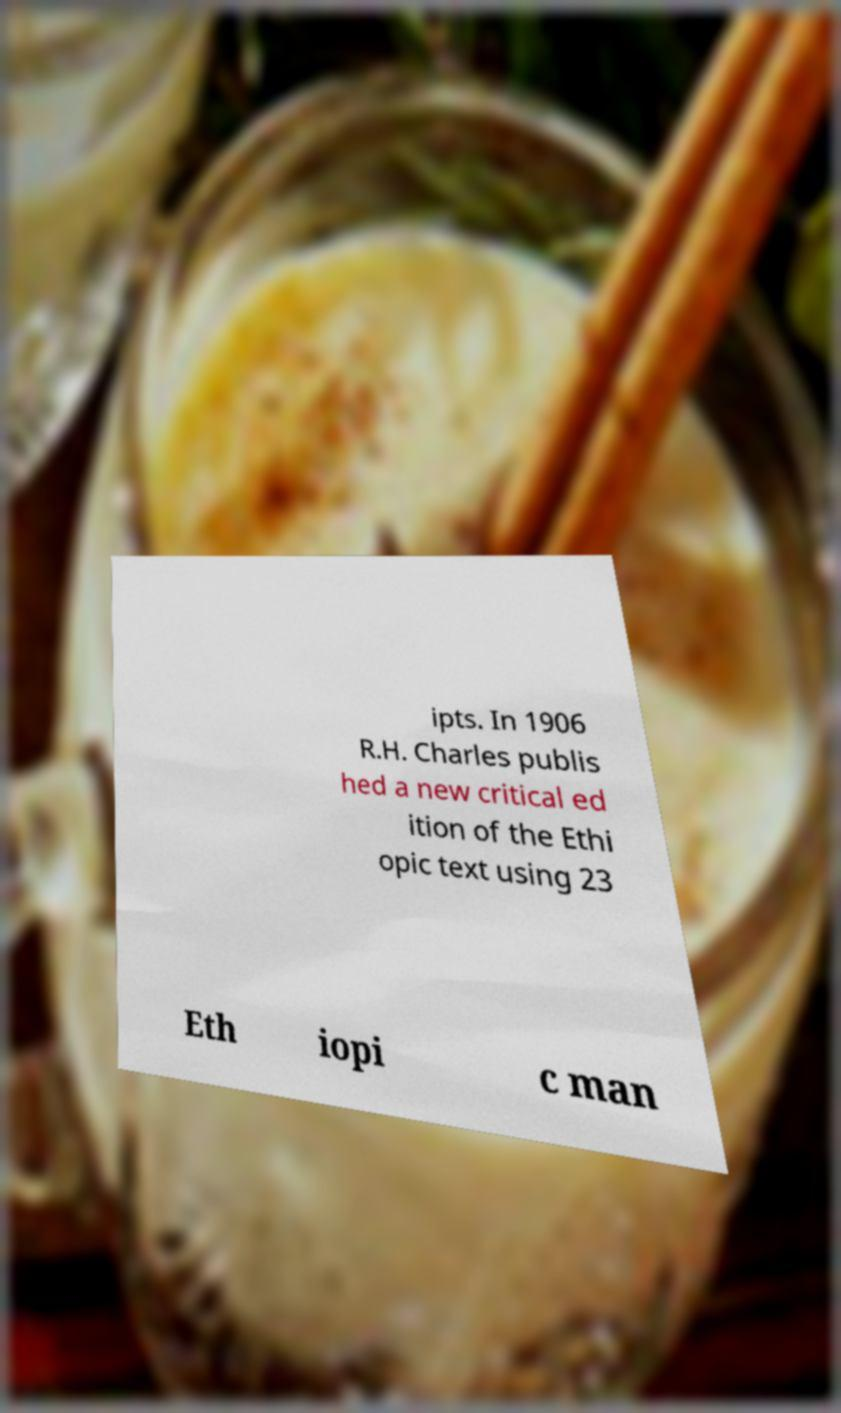Could you assist in decoding the text presented in this image and type it out clearly? ipts. In 1906 R.H. Charles publis hed a new critical ed ition of the Ethi opic text using 23 Eth iopi c man 